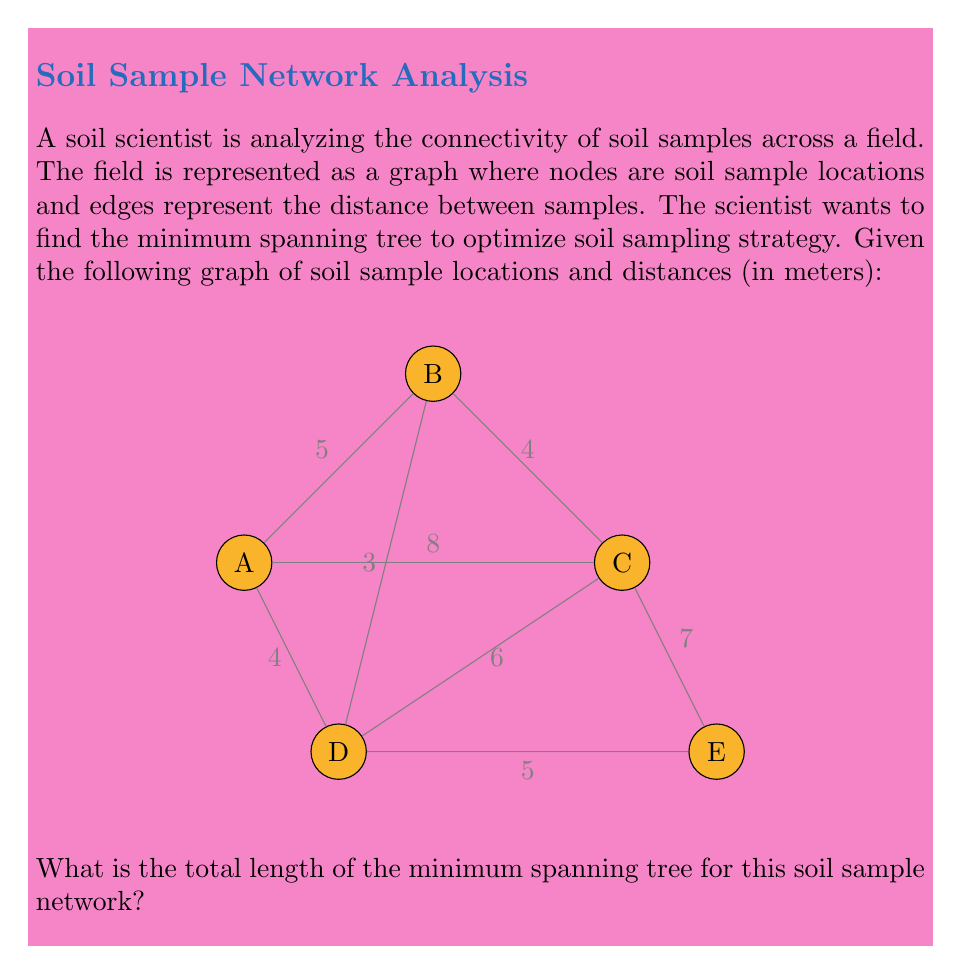Teach me how to tackle this problem. To find the minimum spanning tree (MST) for this soil sample network, we can use Kruskal's algorithm. Here's a step-by-step explanation:

1) First, sort all edges by weight (distance) in ascending order:
   B-D (3m), A-D (4m), B-C (4m), A-B (5m), D-E (5m), C-D (6m), C-E (7m), A-C (8m)

2) Start with an empty MST and add edges in order, skipping those that would create a cycle:

   - Add B-D (3m)
   - Add A-D (4m)
   - Add B-C (4m)
   - Skip A-B (would create cycle A-D-B)
   - Add D-E (5m)

3) At this point, we have connected all nodes (A-D-B-C-E), so we stop.

4) The MST consists of the following edges:
   B-D (3m), A-D (4m), B-C (4m), D-E (5m)

5) Calculate the total length of the MST:
   $$3 + 4 + 4 + 5 = 16$$

Therefore, the total length of the minimum spanning tree is 16 meters.
Answer: 16 meters 